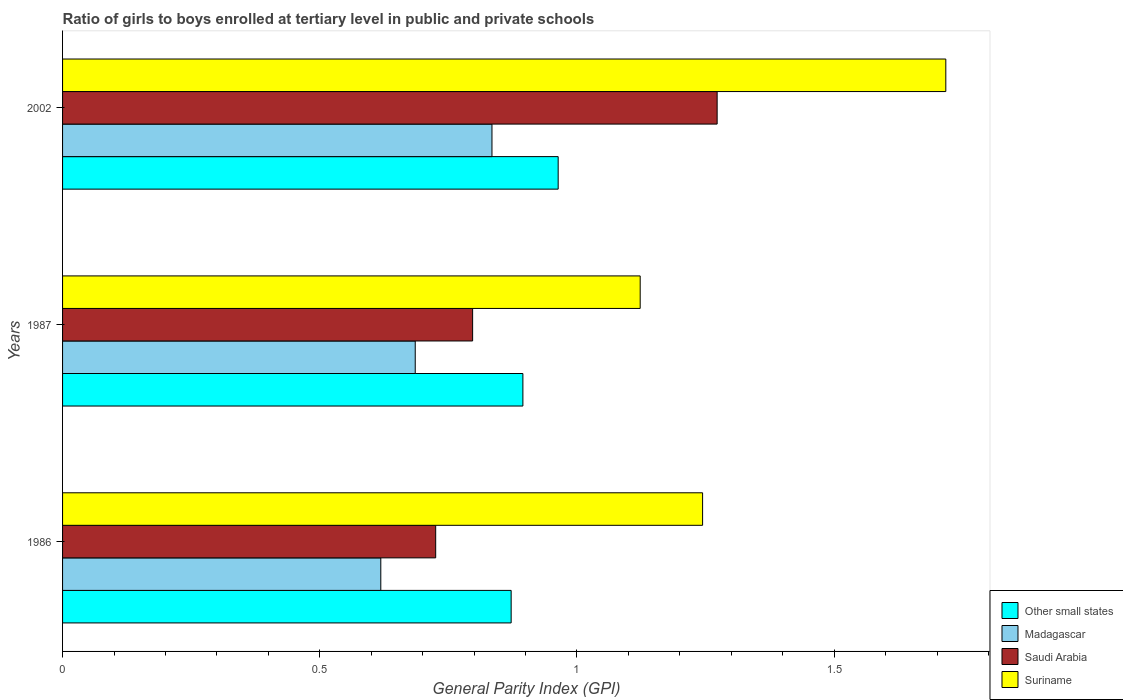How many bars are there on the 3rd tick from the top?
Provide a succinct answer. 4. How many bars are there on the 2nd tick from the bottom?
Give a very brief answer. 4. What is the label of the 2nd group of bars from the top?
Ensure brevity in your answer.  1987. In how many cases, is the number of bars for a given year not equal to the number of legend labels?
Make the answer very short. 0. What is the general parity index in Madagascar in 1987?
Offer a very short reply. 0.69. Across all years, what is the maximum general parity index in Suriname?
Your answer should be compact. 1.72. Across all years, what is the minimum general parity index in Saudi Arabia?
Ensure brevity in your answer.  0.73. In which year was the general parity index in Suriname maximum?
Your answer should be compact. 2002. What is the total general parity index in Saudi Arabia in the graph?
Provide a succinct answer. 2.8. What is the difference between the general parity index in Other small states in 1987 and that in 2002?
Give a very brief answer. -0.07. What is the difference between the general parity index in Suriname in 1987 and the general parity index in Saudi Arabia in 2002?
Offer a very short reply. -0.15. What is the average general parity index in Saudi Arabia per year?
Give a very brief answer. 0.93. In the year 1987, what is the difference between the general parity index in Suriname and general parity index in Saudi Arabia?
Your response must be concise. 0.33. What is the ratio of the general parity index in Suriname in 1986 to that in 1987?
Make the answer very short. 1.11. Is the general parity index in Other small states in 1986 less than that in 2002?
Your answer should be compact. Yes. Is the difference between the general parity index in Suriname in 1986 and 2002 greater than the difference between the general parity index in Saudi Arabia in 1986 and 2002?
Your answer should be very brief. Yes. What is the difference between the highest and the second highest general parity index in Other small states?
Provide a short and direct response. 0.07. What is the difference between the highest and the lowest general parity index in Suriname?
Keep it short and to the point. 0.59. What does the 4th bar from the top in 1987 represents?
Give a very brief answer. Other small states. What does the 3rd bar from the bottom in 1986 represents?
Your answer should be very brief. Saudi Arabia. Is it the case that in every year, the sum of the general parity index in Madagascar and general parity index in Saudi Arabia is greater than the general parity index in Other small states?
Provide a succinct answer. Yes. Are all the bars in the graph horizontal?
Your answer should be very brief. Yes. How many years are there in the graph?
Keep it short and to the point. 3. What is the difference between two consecutive major ticks on the X-axis?
Make the answer very short. 0.5. Does the graph contain grids?
Your response must be concise. No. How many legend labels are there?
Your response must be concise. 4. What is the title of the graph?
Provide a short and direct response. Ratio of girls to boys enrolled at tertiary level in public and private schools. What is the label or title of the X-axis?
Your answer should be very brief. General Parity Index (GPI). What is the label or title of the Y-axis?
Your answer should be very brief. Years. What is the General Parity Index (GPI) of Other small states in 1986?
Your response must be concise. 0.87. What is the General Parity Index (GPI) in Madagascar in 1986?
Provide a short and direct response. 0.62. What is the General Parity Index (GPI) in Saudi Arabia in 1986?
Make the answer very short. 0.73. What is the General Parity Index (GPI) of Suriname in 1986?
Make the answer very short. 1.24. What is the General Parity Index (GPI) of Other small states in 1987?
Provide a succinct answer. 0.89. What is the General Parity Index (GPI) of Madagascar in 1987?
Your answer should be compact. 0.69. What is the General Parity Index (GPI) in Saudi Arabia in 1987?
Keep it short and to the point. 0.8. What is the General Parity Index (GPI) of Suriname in 1987?
Provide a short and direct response. 1.12. What is the General Parity Index (GPI) in Other small states in 2002?
Offer a terse response. 0.96. What is the General Parity Index (GPI) of Madagascar in 2002?
Provide a short and direct response. 0.83. What is the General Parity Index (GPI) of Saudi Arabia in 2002?
Offer a terse response. 1.27. What is the General Parity Index (GPI) in Suriname in 2002?
Offer a very short reply. 1.72. Across all years, what is the maximum General Parity Index (GPI) of Other small states?
Provide a short and direct response. 0.96. Across all years, what is the maximum General Parity Index (GPI) of Madagascar?
Make the answer very short. 0.83. Across all years, what is the maximum General Parity Index (GPI) of Saudi Arabia?
Provide a succinct answer. 1.27. Across all years, what is the maximum General Parity Index (GPI) in Suriname?
Your answer should be very brief. 1.72. Across all years, what is the minimum General Parity Index (GPI) in Other small states?
Your answer should be compact. 0.87. Across all years, what is the minimum General Parity Index (GPI) of Madagascar?
Give a very brief answer. 0.62. Across all years, what is the minimum General Parity Index (GPI) of Saudi Arabia?
Your answer should be compact. 0.73. Across all years, what is the minimum General Parity Index (GPI) in Suriname?
Provide a succinct answer. 1.12. What is the total General Parity Index (GPI) in Other small states in the graph?
Keep it short and to the point. 2.73. What is the total General Parity Index (GPI) in Madagascar in the graph?
Give a very brief answer. 2.14. What is the total General Parity Index (GPI) of Saudi Arabia in the graph?
Make the answer very short. 2.8. What is the total General Parity Index (GPI) in Suriname in the graph?
Keep it short and to the point. 4.08. What is the difference between the General Parity Index (GPI) in Other small states in 1986 and that in 1987?
Keep it short and to the point. -0.02. What is the difference between the General Parity Index (GPI) of Madagascar in 1986 and that in 1987?
Offer a very short reply. -0.07. What is the difference between the General Parity Index (GPI) in Saudi Arabia in 1986 and that in 1987?
Keep it short and to the point. -0.07. What is the difference between the General Parity Index (GPI) in Suriname in 1986 and that in 1987?
Your answer should be compact. 0.12. What is the difference between the General Parity Index (GPI) in Other small states in 1986 and that in 2002?
Give a very brief answer. -0.09. What is the difference between the General Parity Index (GPI) in Madagascar in 1986 and that in 2002?
Your answer should be compact. -0.22. What is the difference between the General Parity Index (GPI) of Saudi Arabia in 1986 and that in 2002?
Ensure brevity in your answer.  -0.55. What is the difference between the General Parity Index (GPI) in Suriname in 1986 and that in 2002?
Provide a succinct answer. -0.47. What is the difference between the General Parity Index (GPI) of Other small states in 1987 and that in 2002?
Offer a very short reply. -0.07. What is the difference between the General Parity Index (GPI) of Madagascar in 1987 and that in 2002?
Your answer should be compact. -0.15. What is the difference between the General Parity Index (GPI) of Saudi Arabia in 1987 and that in 2002?
Your answer should be compact. -0.48. What is the difference between the General Parity Index (GPI) in Suriname in 1987 and that in 2002?
Your response must be concise. -0.59. What is the difference between the General Parity Index (GPI) of Other small states in 1986 and the General Parity Index (GPI) of Madagascar in 1987?
Your answer should be very brief. 0.19. What is the difference between the General Parity Index (GPI) of Other small states in 1986 and the General Parity Index (GPI) of Saudi Arabia in 1987?
Make the answer very short. 0.07. What is the difference between the General Parity Index (GPI) of Other small states in 1986 and the General Parity Index (GPI) of Suriname in 1987?
Keep it short and to the point. -0.25. What is the difference between the General Parity Index (GPI) in Madagascar in 1986 and the General Parity Index (GPI) in Saudi Arabia in 1987?
Keep it short and to the point. -0.18. What is the difference between the General Parity Index (GPI) of Madagascar in 1986 and the General Parity Index (GPI) of Suriname in 1987?
Keep it short and to the point. -0.5. What is the difference between the General Parity Index (GPI) of Saudi Arabia in 1986 and the General Parity Index (GPI) of Suriname in 1987?
Provide a short and direct response. -0.4. What is the difference between the General Parity Index (GPI) of Other small states in 1986 and the General Parity Index (GPI) of Madagascar in 2002?
Offer a terse response. 0.04. What is the difference between the General Parity Index (GPI) of Other small states in 1986 and the General Parity Index (GPI) of Saudi Arabia in 2002?
Your answer should be very brief. -0.4. What is the difference between the General Parity Index (GPI) of Other small states in 1986 and the General Parity Index (GPI) of Suriname in 2002?
Your response must be concise. -0.84. What is the difference between the General Parity Index (GPI) of Madagascar in 1986 and the General Parity Index (GPI) of Saudi Arabia in 2002?
Your answer should be compact. -0.65. What is the difference between the General Parity Index (GPI) of Madagascar in 1986 and the General Parity Index (GPI) of Suriname in 2002?
Offer a very short reply. -1.1. What is the difference between the General Parity Index (GPI) of Saudi Arabia in 1986 and the General Parity Index (GPI) of Suriname in 2002?
Your answer should be very brief. -0.99. What is the difference between the General Parity Index (GPI) of Other small states in 1987 and the General Parity Index (GPI) of Madagascar in 2002?
Make the answer very short. 0.06. What is the difference between the General Parity Index (GPI) of Other small states in 1987 and the General Parity Index (GPI) of Saudi Arabia in 2002?
Offer a terse response. -0.38. What is the difference between the General Parity Index (GPI) of Other small states in 1987 and the General Parity Index (GPI) of Suriname in 2002?
Give a very brief answer. -0.82. What is the difference between the General Parity Index (GPI) in Madagascar in 1987 and the General Parity Index (GPI) in Saudi Arabia in 2002?
Ensure brevity in your answer.  -0.59. What is the difference between the General Parity Index (GPI) in Madagascar in 1987 and the General Parity Index (GPI) in Suriname in 2002?
Your answer should be very brief. -1.03. What is the difference between the General Parity Index (GPI) of Saudi Arabia in 1987 and the General Parity Index (GPI) of Suriname in 2002?
Your answer should be compact. -0.92. What is the average General Parity Index (GPI) in Other small states per year?
Offer a very short reply. 0.91. What is the average General Parity Index (GPI) of Madagascar per year?
Provide a short and direct response. 0.71. What is the average General Parity Index (GPI) of Saudi Arabia per year?
Provide a short and direct response. 0.93. What is the average General Parity Index (GPI) in Suriname per year?
Offer a very short reply. 1.36. In the year 1986, what is the difference between the General Parity Index (GPI) of Other small states and General Parity Index (GPI) of Madagascar?
Give a very brief answer. 0.25. In the year 1986, what is the difference between the General Parity Index (GPI) in Other small states and General Parity Index (GPI) in Saudi Arabia?
Ensure brevity in your answer.  0.15. In the year 1986, what is the difference between the General Parity Index (GPI) of Other small states and General Parity Index (GPI) of Suriname?
Your response must be concise. -0.37. In the year 1986, what is the difference between the General Parity Index (GPI) in Madagascar and General Parity Index (GPI) in Saudi Arabia?
Offer a very short reply. -0.11. In the year 1986, what is the difference between the General Parity Index (GPI) in Madagascar and General Parity Index (GPI) in Suriname?
Provide a succinct answer. -0.63. In the year 1986, what is the difference between the General Parity Index (GPI) of Saudi Arabia and General Parity Index (GPI) of Suriname?
Your answer should be very brief. -0.52. In the year 1987, what is the difference between the General Parity Index (GPI) of Other small states and General Parity Index (GPI) of Madagascar?
Offer a terse response. 0.21. In the year 1987, what is the difference between the General Parity Index (GPI) of Other small states and General Parity Index (GPI) of Saudi Arabia?
Your answer should be very brief. 0.1. In the year 1987, what is the difference between the General Parity Index (GPI) of Other small states and General Parity Index (GPI) of Suriname?
Your response must be concise. -0.23. In the year 1987, what is the difference between the General Parity Index (GPI) of Madagascar and General Parity Index (GPI) of Saudi Arabia?
Provide a succinct answer. -0.11. In the year 1987, what is the difference between the General Parity Index (GPI) of Madagascar and General Parity Index (GPI) of Suriname?
Offer a terse response. -0.44. In the year 1987, what is the difference between the General Parity Index (GPI) in Saudi Arabia and General Parity Index (GPI) in Suriname?
Provide a short and direct response. -0.33. In the year 2002, what is the difference between the General Parity Index (GPI) of Other small states and General Parity Index (GPI) of Madagascar?
Your answer should be very brief. 0.13. In the year 2002, what is the difference between the General Parity Index (GPI) in Other small states and General Parity Index (GPI) in Saudi Arabia?
Provide a short and direct response. -0.31. In the year 2002, what is the difference between the General Parity Index (GPI) in Other small states and General Parity Index (GPI) in Suriname?
Offer a very short reply. -0.75. In the year 2002, what is the difference between the General Parity Index (GPI) of Madagascar and General Parity Index (GPI) of Saudi Arabia?
Keep it short and to the point. -0.44. In the year 2002, what is the difference between the General Parity Index (GPI) of Madagascar and General Parity Index (GPI) of Suriname?
Keep it short and to the point. -0.88. In the year 2002, what is the difference between the General Parity Index (GPI) in Saudi Arabia and General Parity Index (GPI) in Suriname?
Ensure brevity in your answer.  -0.44. What is the ratio of the General Parity Index (GPI) of Other small states in 1986 to that in 1987?
Make the answer very short. 0.97. What is the ratio of the General Parity Index (GPI) of Madagascar in 1986 to that in 1987?
Provide a succinct answer. 0.9. What is the ratio of the General Parity Index (GPI) of Saudi Arabia in 1986 to that in 1987?
Your answer should be compact. 0.91. What is the ratio of the General Parity Index (GPI) of Suriname in 1986 to that in 1987?
Make the answer very short. 1.11. What is the ratio of the General Parity Index (GPI) in Other small states in 1986 to that in 2002?
Ensure brevity in your answer.  0.91. What is the ratio of the General Parity Index (GPI) of Madagascar in 1986 to that in 2002?
Offer a very short reply. 0.74. What is the ratio of the General Parity Index (GPI) in Saudi Arabia in 1986 to that in 2002?
Provide a short and direct response. 0.57. What is the ratio of the General Parity Index (GPI) in Suriname in 1986 to that in 2002?
Your response must be concise. 0.72. What is the ratio of the General Parity Index (GPI) in Other small states in 1987 to that in 2002?
Your answer should be very brief. 0.93. What is the ratio of the General Parity Index (GPI) of Madagascar in 1987 to that in 2002?
Give a very brief answer. 0.82. What is the ratio of the General Parity Index (GPI) of Saudi Arabia in 1987 to that in 2002?
Keep it short and to the point. 0.63. What is the ratio of the General Parity Index (GPI) in Suriname in 1987 to that in 2002?
Ensure brevity in your answer.  0.65. What is the difference between the highest and the second highest General Parity Index (GPI) in Other small states?
Your answer should be very brief. 0.07. What is the difference between the highest and the second highest General Parity Index (GPI) of Madagascar?
Your answer should be compact. 0.15. What is the difference between the highest and the second highest General Parity Index (GPI) of Saudi Arabia?
Offer a very short reply. 0.48. What is the difference between the highest and the second highest General Parity Index (GPI) in Suriname?
Keep it short and to the point. 0.47. What is the difference between the highest and the lowest General Parity Index (GPI) of Other small states?
Provide a short and direct response. 0.09. What is the difference between the highest and the lowest General Parity Index (GPI) of Madagascar?
Ensure brevity in your answer.  0.22. What is the difference between the highest and the lowest General Parity Index (GPI) of Saudi Arabia?
Provide a short and direct response. 0.55. What is the difference between the highest and the lowest General Parity Index (GPI) of Suriname?
Offer a terse response. 0.59. 